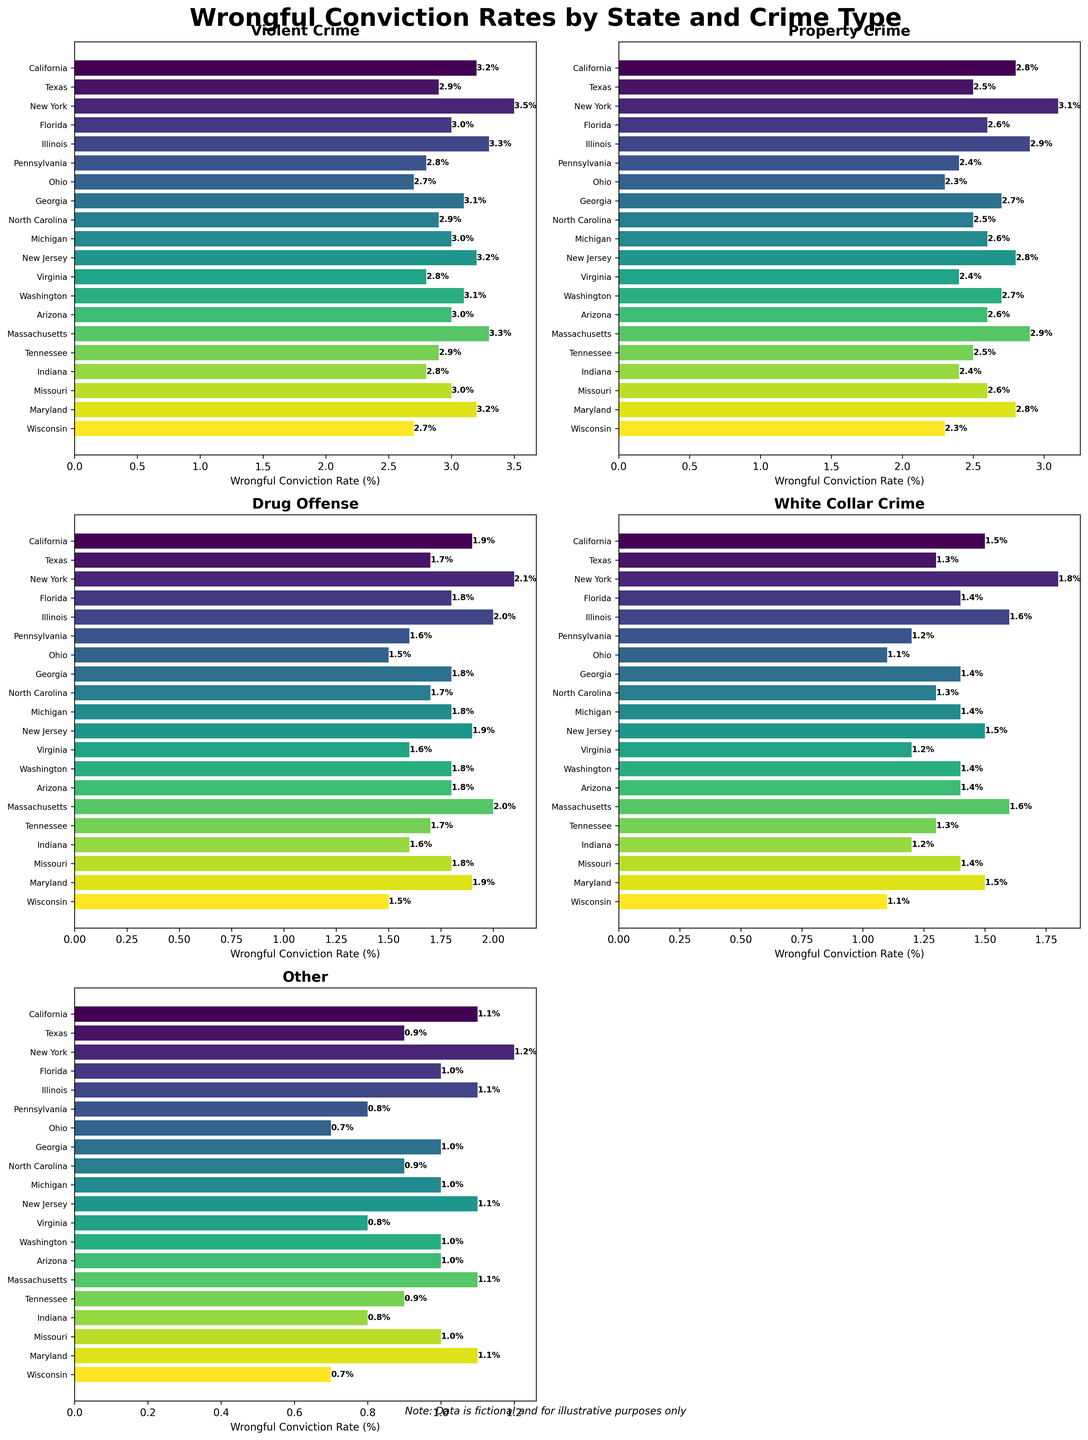Which state has the highest wrongful conviction rate for violent crime? The plot labeled "Violent Crime" shows New York with the tallest bar, indicating the highest wrongful conviction rate.
Answer: New York Which state has the lowest wrongful conviction rate for drug offenses? The plot labeled "Drug Offense" shows Ohio and Wisconsin with the shortest bars, indicating the lowest wrongful conviction rates.
Answer: Ohio and Wisconsin What's the difference in wrongful conviction rates for property crime between California and Texas? The plot labeled "Property Crime" shows California at 2.8% and Texas at 2.5%. The difference is calculated as 2.8% - 2.5%.
Answer: 0.3% Which type of crime in Pennsylvania has the highest wrongful conviction rate? By examining the bars for Pennsylvania across the different subplots, "Violent Crime" has the tallest bar at 2.8%.
Answer: Violent Crime What is the average wrongful conviction rate for white collar crime across all states? Sum the rates for white collar crime: (1.5+1.3+1.8+1.4+1.6+1.2+1.1+1.4+1.3+1.4+1.5+1.2+1.4+1.4+1.6+1.3+1.2+1.5+1.1) = 25.2. Divide by the number of states (19).
Answer: 1.32% Between New Jersey and Maryland, which has a higher wrongful conviction rate for white collar crime? The plot labeled "White Collar Crime" shows New Jersey and Maryland both at 1.5%, indicating they are equal.
Answer: Equal Considering violent crime and drug offenses, in which states does the wrongful conviction rate for violent crime exceed the rate for drug offenses by more than 1 percentage point? Compare the bars for violent crime and drug offenses in each state: California (3.2-1.9=1.3), Texas (2.9-1.7=1.2), New York (3.5-2.1=1.4), Illinois (3.3-2.0=1.3), Massachusetts (3.3-2.0=1.3).
Answer: California, Texas, New York, Illinois, Massachusetts Are there any states where the wrongful conviction rate for "Other" crimes is higher than for property crimes? Compare the bars for "Other" and "Property Crime" in each state, none of the states have higher bars for "Other" than for "Property Crime".
Answer: No What is the overall trend in wrongful conviction rates across the different crime types for Ohio? By looking at Ohio across different subplots: Violent Crime (2.7), Property Crime (2.3), Drug Offense (1.5), White Collar Crime (1.1), Other (0.7). The rates consistently decrease from violent crime to other.
Answer: Decreasing trend Which crime type shows the least variation in wrongful conviction rates across all states? Comparing the bar lengths in each subplot, "Drug Offense" has closely clustered bars, indicating the least variation.
Answer: Drug Offense 